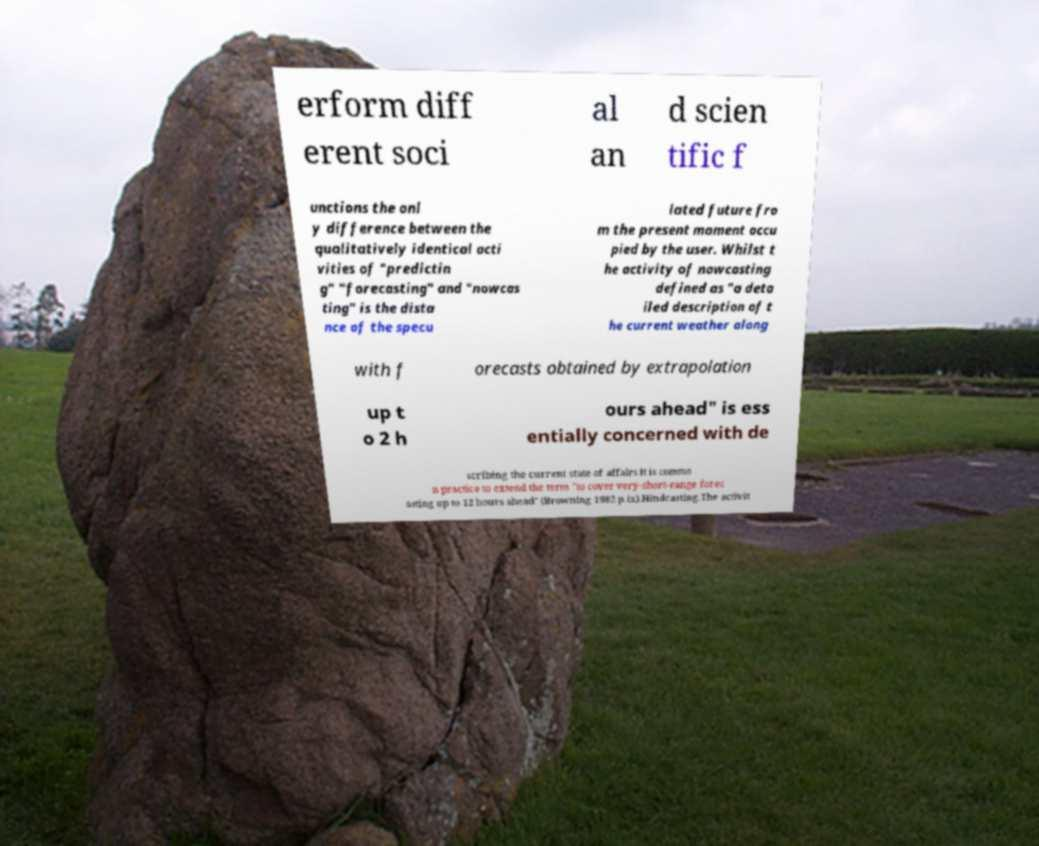What messages or text are displayed in this image? I need them in a readable, typed format. erform diff erent soci al an d scien tific f unctions the onl y difference between the qualitatively identical acti vities of "predictin g" "forecasting" and "nowcas ting" is the dista nce of the specu lated future fro m the present moment occu pied by the user. Whilst t he activity of nowcasting defined as "a deta iled description of t he current weather along with f orecasts obtained by extrapolation up t o 2 h ours ahead" is ess entially concerned with de scribing the current state of affairs it is commo n practice to extend the term "to cover very-short-range forec asting up to 12 hours ahead" (Browning 1982 p.ix).Hindcasting.The activit 